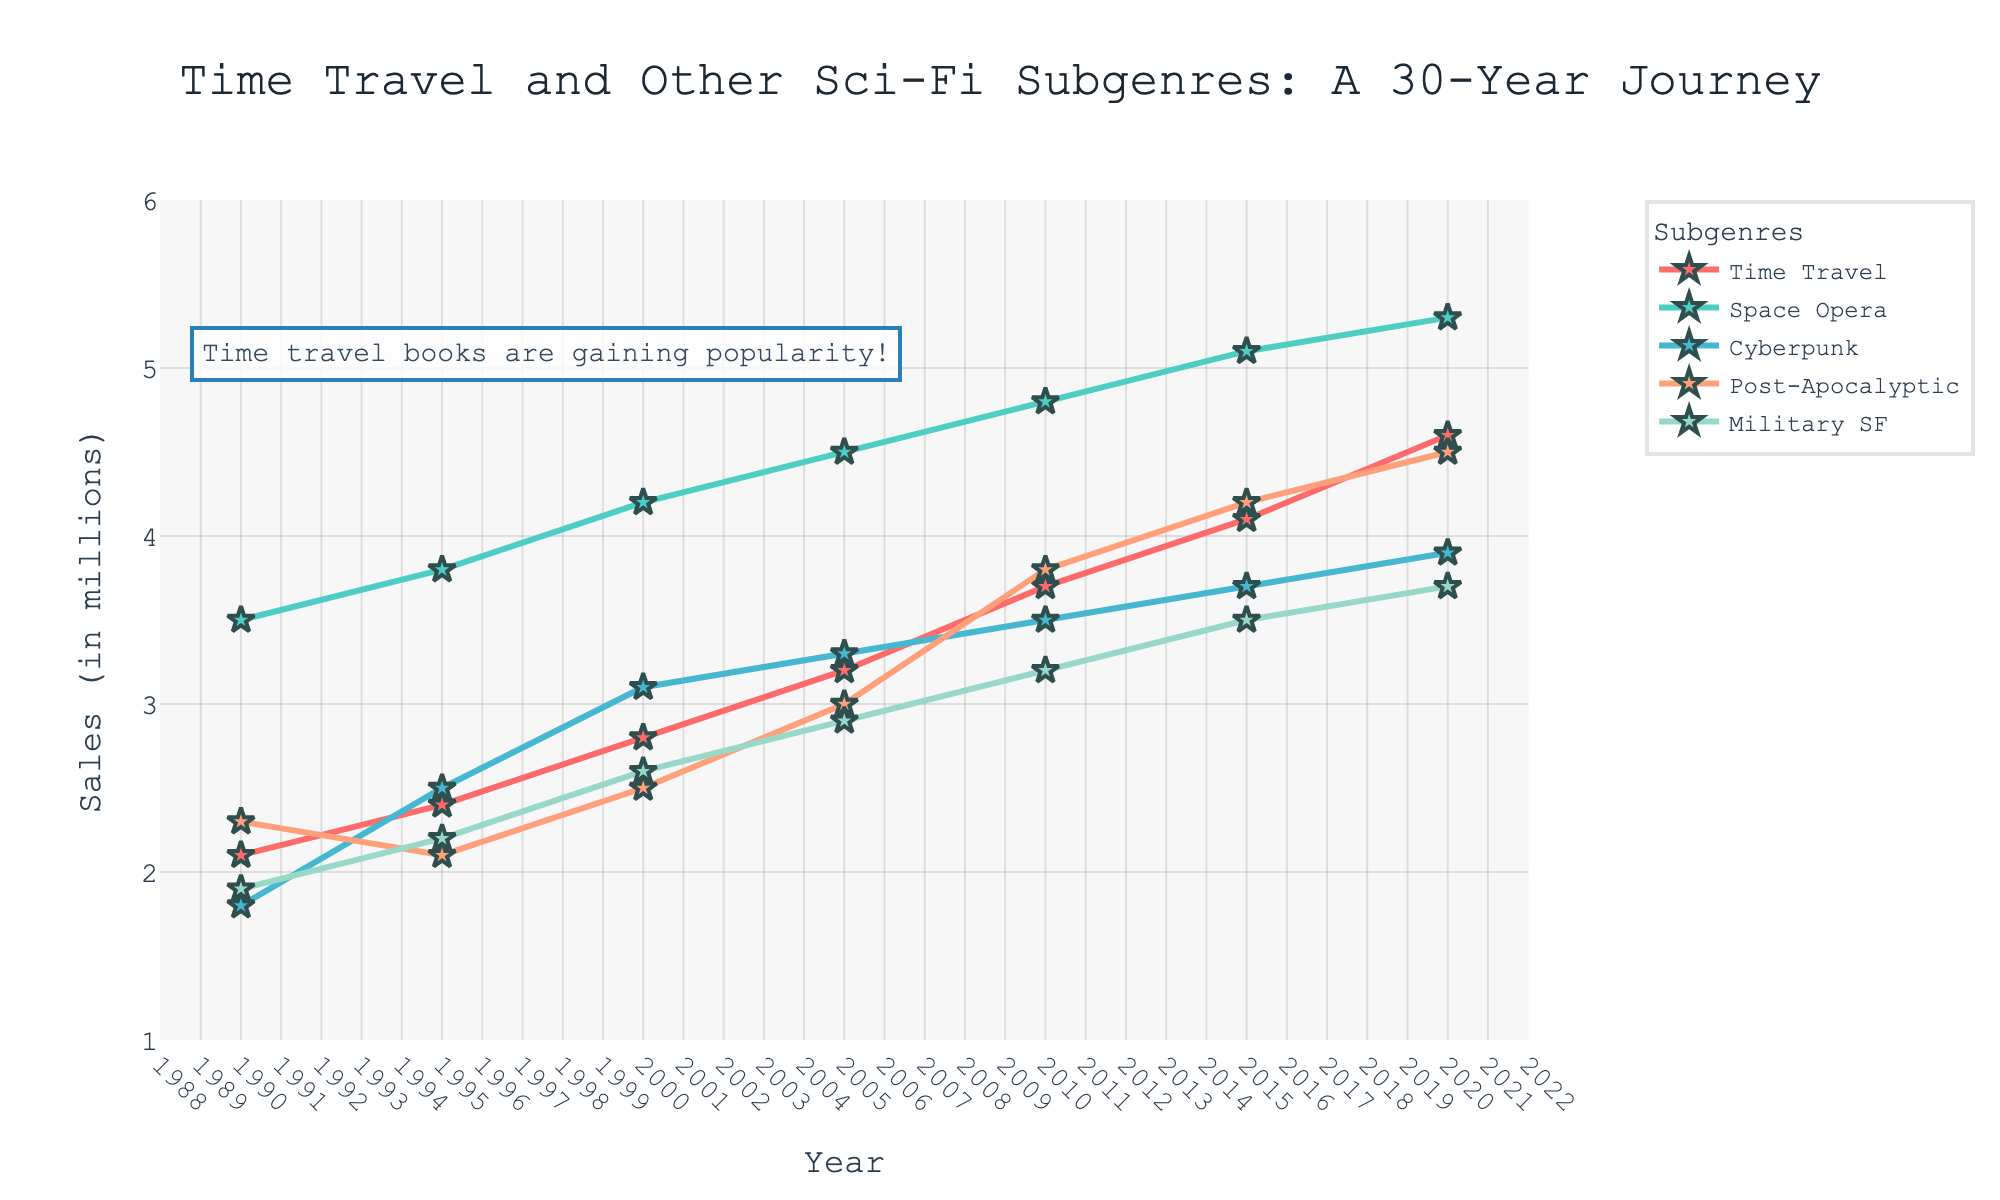What's the trend in sales for time travel books from 1990 to 2020? Observing the line representing time travel subgenre in the figure, it shows a consistent upward trend from 2.1 to 4.6 million sales over the three decades.
Answer: Consistent upward trend Which subgenre had the highest sales in 2020? Referring to the 2020 data points, the space opera subgenre has the highest sales, reaching 5.3 million.
Answer: Space Opera By how much did post-apocalyptic book sales increase from 1990 to 2020? The sales for post-apocalyptic books in 1990 were 2.3 million and in 2020 were 4.5 million. The increase is 4.5 - 2.3 = 2.2 million.
Answer: 2.2 million Which color represents the cyberpunk subgenre in the chart? The color associated with the cyberpunk line is light blue.
Answer: Light blue Which subgenre had the most stable sales over the three decades? To determine stability, check for the subgenre with the smallest fluctuations in sales. Military SF sales increased from 1.9 to 3.7 million, indicating it had fewer and smaller fluctuations compared to the others.
Answer: Military SF By what percentage did time travel book sales increase from 1990 to 2020? The percentage increase is calculated by [(2020 sales - 1990 sales) / 1990 sales] * 100. For time travel books, this is [(4.6 - 2.1) / 2.1] * 100 = 119.05%.
Answer: 119.05% What visual clue indicates the popularity of time travel books in the chart? The annotation "Time travel books are gaining popularity!" and an increasing line trend visually indicate their rising popularity.
Answer: Increasing line trend and annotation 